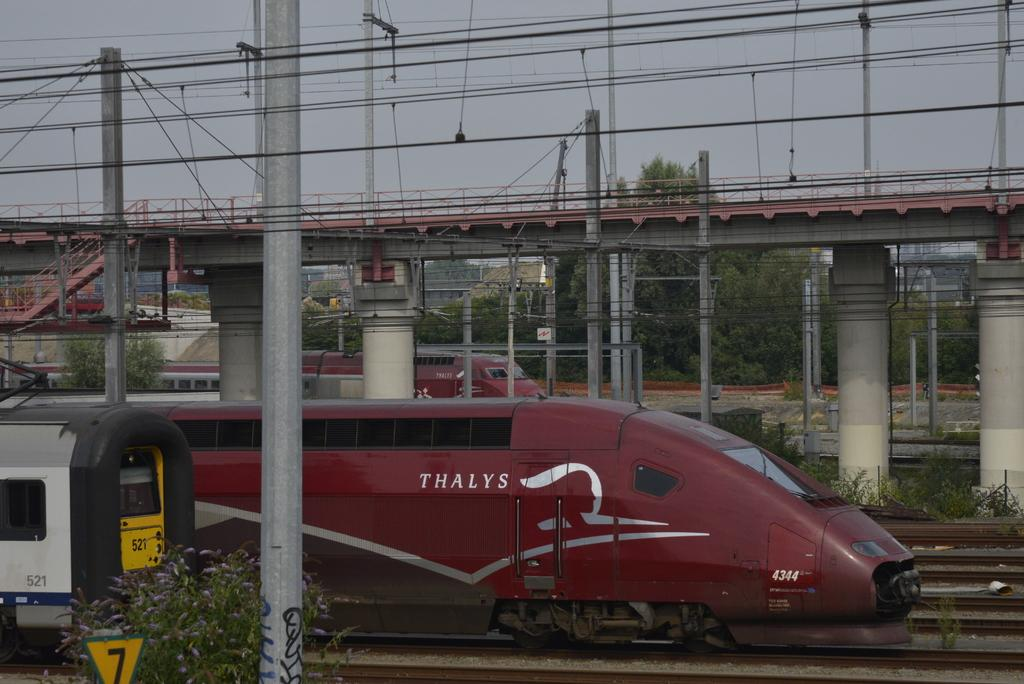Provide a one-sentence caption for the provided image. A maroon thalys train behind another car 521 of another train. 